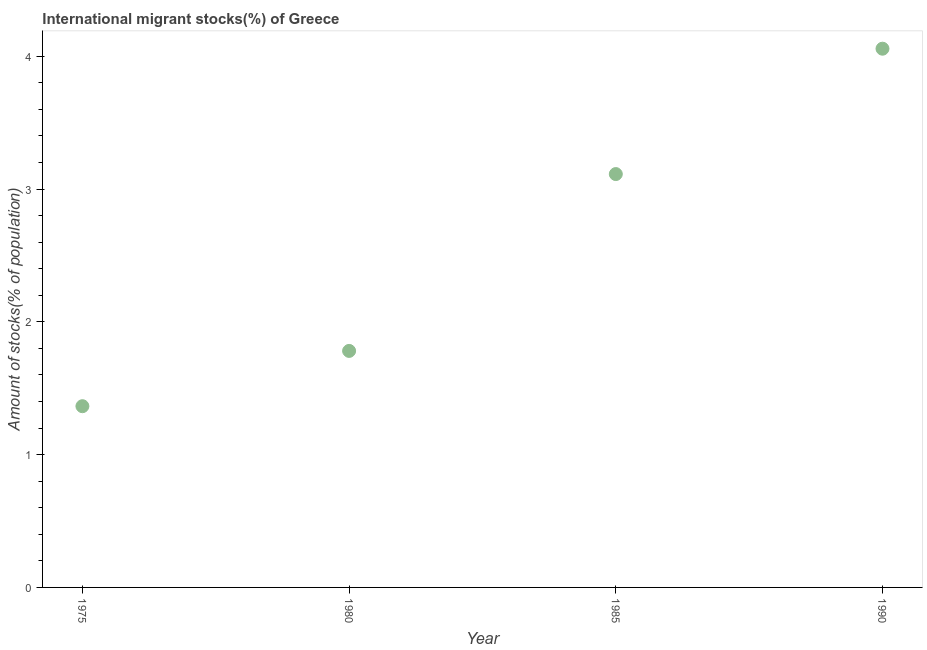What is the number of international migrant stocks in 1990?
Offer a very short reply. 4.06. Across all years, what is the maximum number of international migrant stocks?
Your answer should be compact. 4.06. Across all years, what is the minimum number of international migrant stocks?
Provide a short and direct response. 1.36. In which year was the number of international migrant stocks minimum?
Your answer should be compact. 1975. What is the sum of the number of international migrant stocks?
Your answer should be very brief. 10.32. What is the difference between the number of international migrant stocks in 1980 and 1990?
Your answer should be compact. -2.28. What is the average number of international migrant stocks per year?
Give a very brief answer. 2.58. What is the median number of international migrant stocks?
Your answer should be very brief. 2.45. What is the ratio of the number of international migrant stocks in 1980 to that in 1985?
Give a very brief answer. 0.57. Is the difference between the number of international migrant stocks in 1985 and 1990 greater than the difference between any two years?
Offer a very short reply. No. What is the difference between the highest and the second highest number of international migrant stocks?
Make the answer very short. 0.94. Is the sum of the number of international migrant stocks in 1985 and 1990 greater than the maximum number of international migrant stocks across all years?
Make the answer very short. Yes. What is the difference between the highest and the lowest number of international migrant stocks?
Your answer should be very brief. 2.69. In how many years, is the number of international migrant stocks greater than the average number of international migrant stocks taken over all years?
Provide a succinct answer. 2. How many dotlines are there?
Ensure brevity in your answer.  1. How many years are there in the graph?
Provide a short and direct response. 4. What is the title of the graph?
Keep it short and to the point. International migrant stocks(%) of Greece. What is the label or title of the X-axis?
Give a very brief answer. Year. What is the label or title of the Y-axis?
Offer a very short reply. Amount of stocks(% of population). What is the Amount of stocks(% of population) in 1975?
Your response must be concise. 1.36. What is the Amount of stocks(% of population) in 1980?
Your answer should be compact. 1.78. What is the Amount of stocks(% of population) in 1985?
Provide a succinct answer. 3.11. What is the Amount of stocks(% of population) in 1990?
Ensure brevity in your answer.  4.06. What is the difference between the Amount of stocks(% of population) in 1975 and 1980?
Keep it short and to the point. -0.42. What is the difference between the Amount of stocks(% of population) in 1975 and 1985?
Keep it short and to the point. -1.75. What is the difference between the Amount of stocks(% of population) in 1975 and 1990?
Your answer should be compact. -2.69. What is the difference between the Amount of stocks(% of population) in 1980 and 1985?
Keep it short and to the point. -1.33. What is the difference between the Amount of stocks(% of population) in 1980 and 1990?
Your answer should be compact. -2.28. What is the difference between the Amount of stocks(% of population) in 1985 and 1990?
Ensure brevity in your answer.  -0.94. What is the ratio of the Amount of stocks(% of population) in 1975 to that in 1980?
Your answer should be very brief. 0.77. What is the ratio of the Amount of stocks(% of population) in 1975 to that in 1985?
Offer a very short reply. 0.44. What is the ratio of the Amount of stocks(% of population) in 1975 to that in 1990?
Offer a terse response. 0.34. What is the ratio of the Amount of stocks(% of population) in 1980 to that in 1985?
Give a very brief answer. 0.57. What is the ratio of the Amount of stocks(% of population) in 1980 to that in 1990?
Your answer should be compact. 0.44. What is the ratio of the Amount of stocks(% of population) in 1985 to that in 1990?
Your response must be concise. 0.77. 